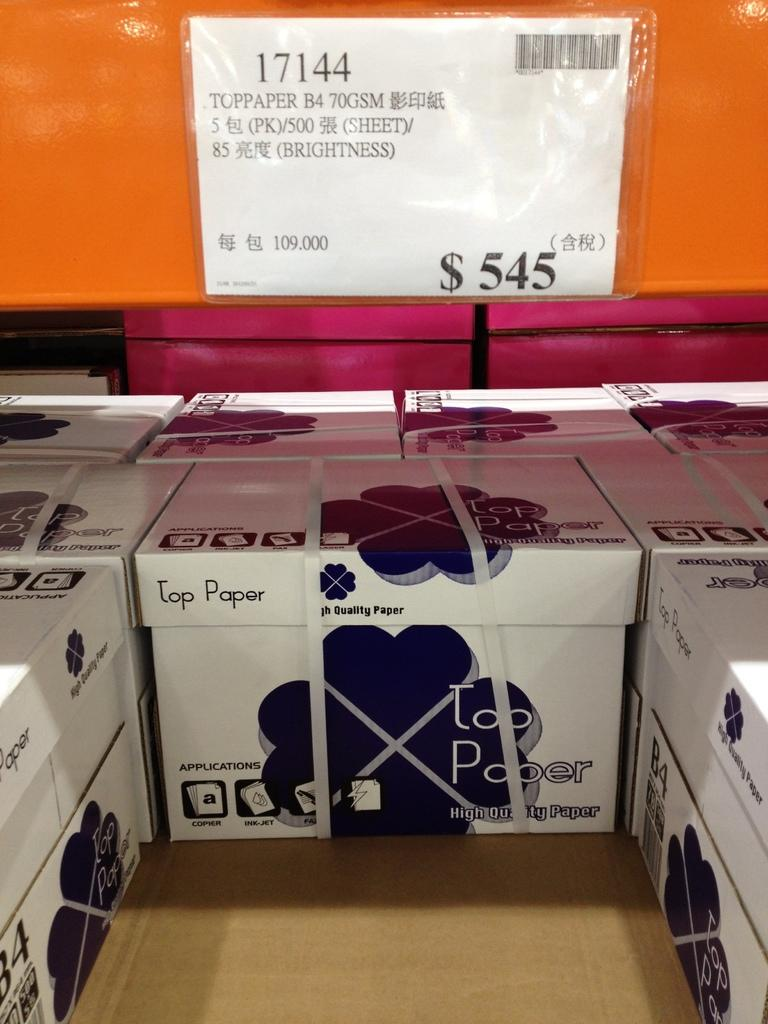<image>
Render a clear and concise summary of the photo. Boxes of Top Paper that each cost $545 